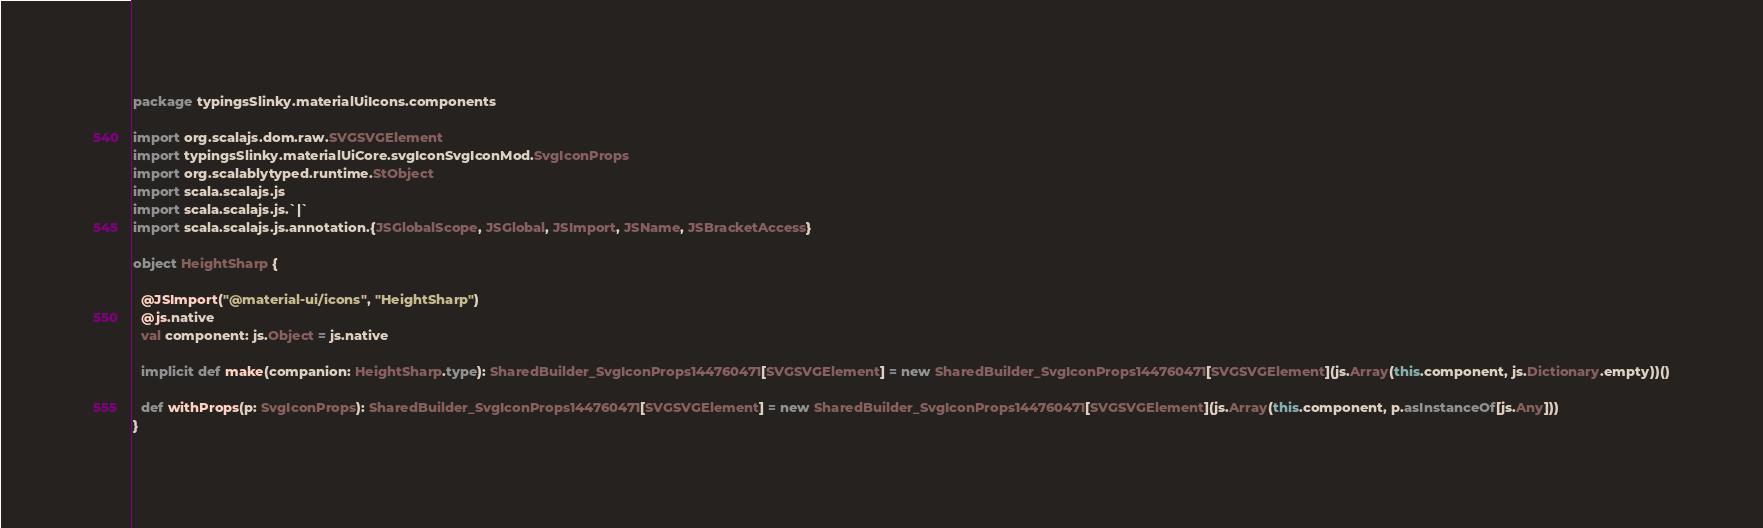Convert code to text. <code><loc_0><loc_0><loc_500><loc_500><_Scala_>package typingsSlinky.materialUiIcons.components

import org.scalajs.dom.raw.SVGSVGElement
import typingsSlinky.materialUiCore.svgIconSvgIconMod.SvgIconProps
import org.scalablytyped.runtime.StObject
import scala.scalajs.js
import scala.scalajs.js.`|`
import scala.scalajs.js.annotation.{JSGlobalScope, JSGlobal, JSImport, JSName, JSBracketAccess}

object HeightSharp {
  
  @JSImport("@material-ui/icons", "HeightSharp")
  @js.native
  val component: js.Object = js.native
  
  implicit def make(companion: HeightSharp.type): SharedBuilder_SvgIconProps144760471[SVGSVGElement] = new SharedBuilder_SvgIconProps144760471[SVGSVGElement](js.Array(this.component, js.Dictionary.empty))()
  
  def withProps(p: SvgIconProps): SharedBuilder_SvgIconProps144760471[SVGSVGElement] = new SharedBuilder_SvgIconProps144760471[SVGSVGElement](js.Array(this.component, p.asInstanceOf[js.Any]))
}
</code> 